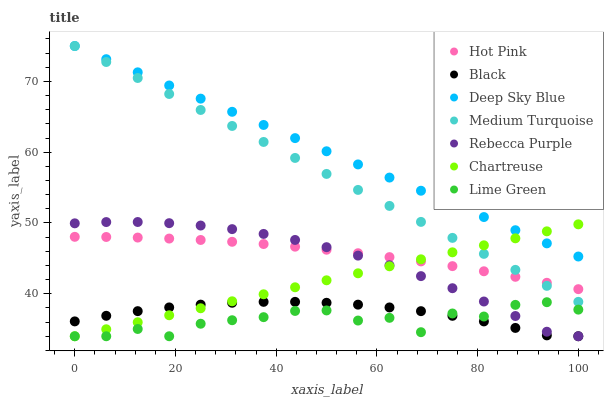Does Lime Green have the minimum area under the curve?
Answer yes or no. Yes. Does Deep Sky Blue have the maximum area under the curve?
Answer yes or no. Yes. Does Hot Pink have the minimum area under the curve?
Answer yes or no. No. Does Hot Pink have the maximum area under the curve?
Answer yes or no. No. Is Chartreuse the smoothest?
Answer yes or no. Yes. Is Lime Green the roughest?
Answer yes or no. Yes. Is Hot Pink the smoothest?
Answer yes or no. No. Is Hot Pink the roughest?
Answer yes or no. No. Does Chartreuse have the lowest value?
Answer yes or no. Yes. Does Hot Pink have the lowest value?
Answer yes or no. No. Does Medium Turquoise have the highest value?
Answer yes or no. Yes. Does Hot Pink have the highest value?
Answer yes or no. No. Is Black less than Deep Sky Blue?
Answer yes or no. Yes. Is Deep Sky Blue greater than Lime Green?
Answer yes or no. Yes. Does Chartreuse intersect Deep Sky Blue?
Answer yes or no. Yes. Is Chartreuse less than Deep Sky Blue?
Answer yes or no. No. Is Chartreuse greater than Deep Sky Blue?
Answer yes or no. No. Does Black intersect Deep Sky Blue?
Answer yes or no. No. 